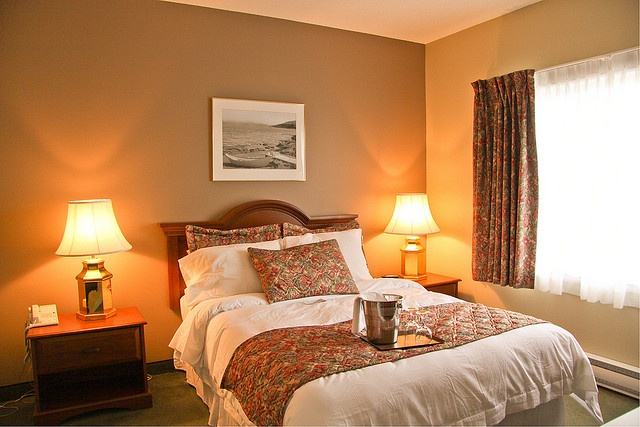Describe the objects in this image and their specific colors. I can see bed in maroon, tan, gray, and brown tones, wine glass in maroon, orange, salmon, white, and brown tones, and wine glass in maroon, orange, ivory, brown, and tan tones in this image. 